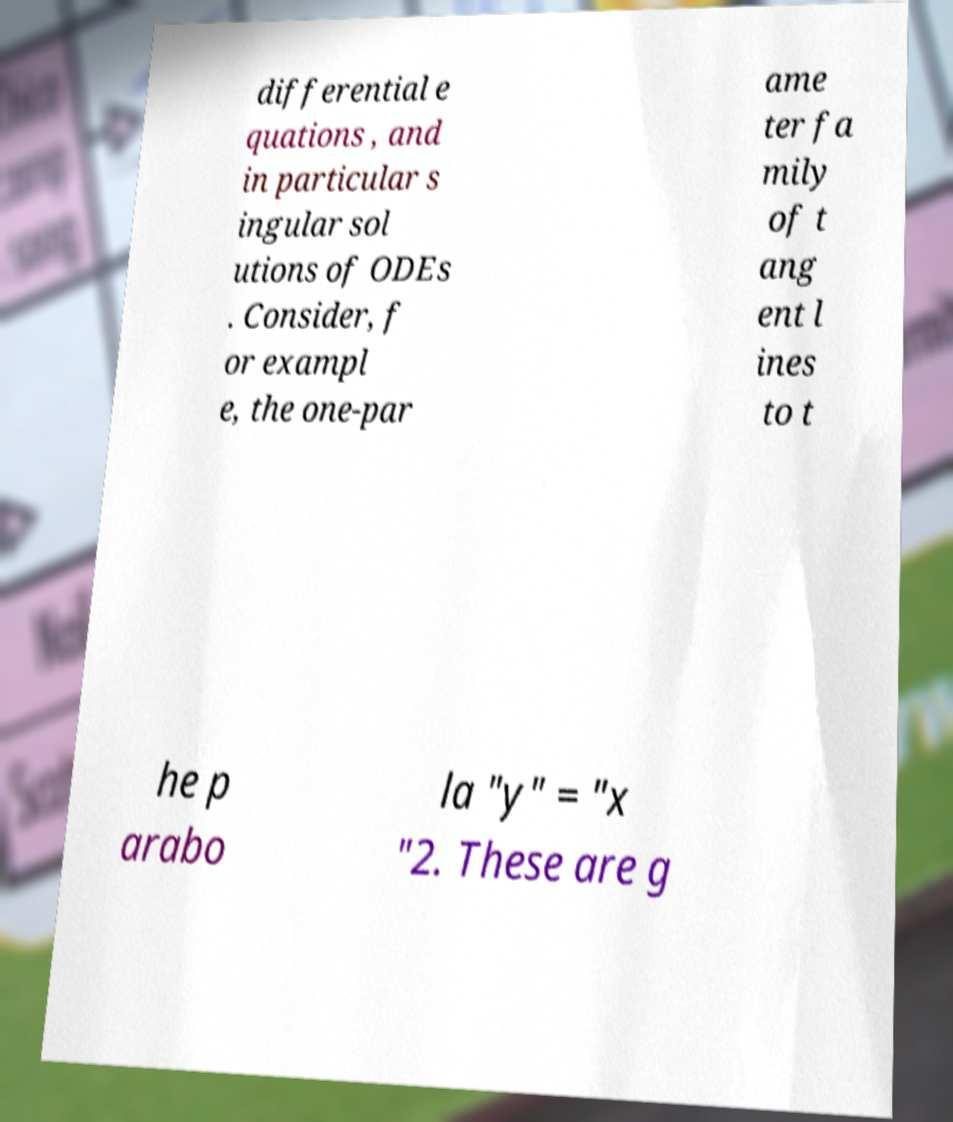I need the written content from this picture converted into text. Can you do that? differential e quations , and in particular s ingular sol utions of ODEs . Consider, f or exampl e, the one-par ame ter fa mily of t ang ent l ines to t he p arabo la "y" = "x "2. These are g 